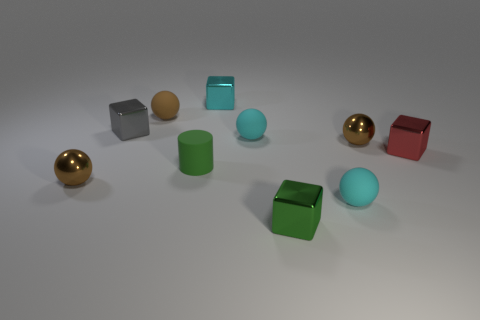What is the material of the cyan cube to the right of the rubber cylinder?
Make the answer very short. Metal. What number of other objects are there of the same size as the gray cube?
Offer a terse response. 9. There is a gray cube; does it have the same size as the brown shiny sphere on the right side of the tiny gray metal block?
Make the answer very short. Yes. There is a tiny brown metal object that is on the right side of the small cyan cube right of the green thing left of the tiny cyan metal cube; what is its shape?
Your answer should be very brief. Sphere. Are there fewer small green shiny blocks than shiny spheres?
Ensure brevity in your answer.  Yes. There is a tiny matte cylinder; are there any tiny red metallic cubes to the left of it?
Make the answer very short. No. What is the shape of the small brown object that is both right of the gray thing and on the left side of the small green metallic thing?
Make the answer very short. Sphere. Is there a gray thing of the same shape as the cyan shiny thing?
Your answer should be very brief. Yes. There is a ball that is on the left side of the tiny gray shiny cube; is it the same size as the matte ball behind the gray metal thing?
Offer a terse response. Yes. Is the number of yellow shiny cylinders greater than the number of small red metal cubes?
Your response must be concise. No. 